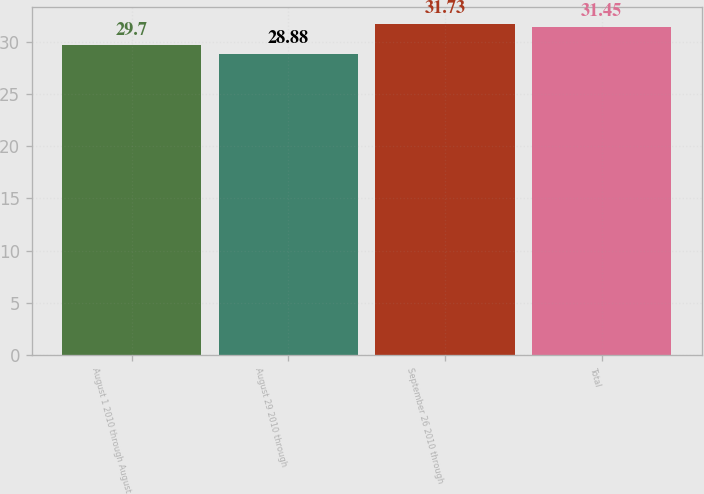Convert chart to OTSL. <chart><loc_0><loc_0><loc_500><loc_500><bar_chart><fcel>August 1 2010 through August<fcel>August 29 2010 through<fcel>September 26 2010 through<fcel>Total<nl><fcel>29.7<fcel>28.88<fcel>31.73<fcel>31.45<nl></chart> 